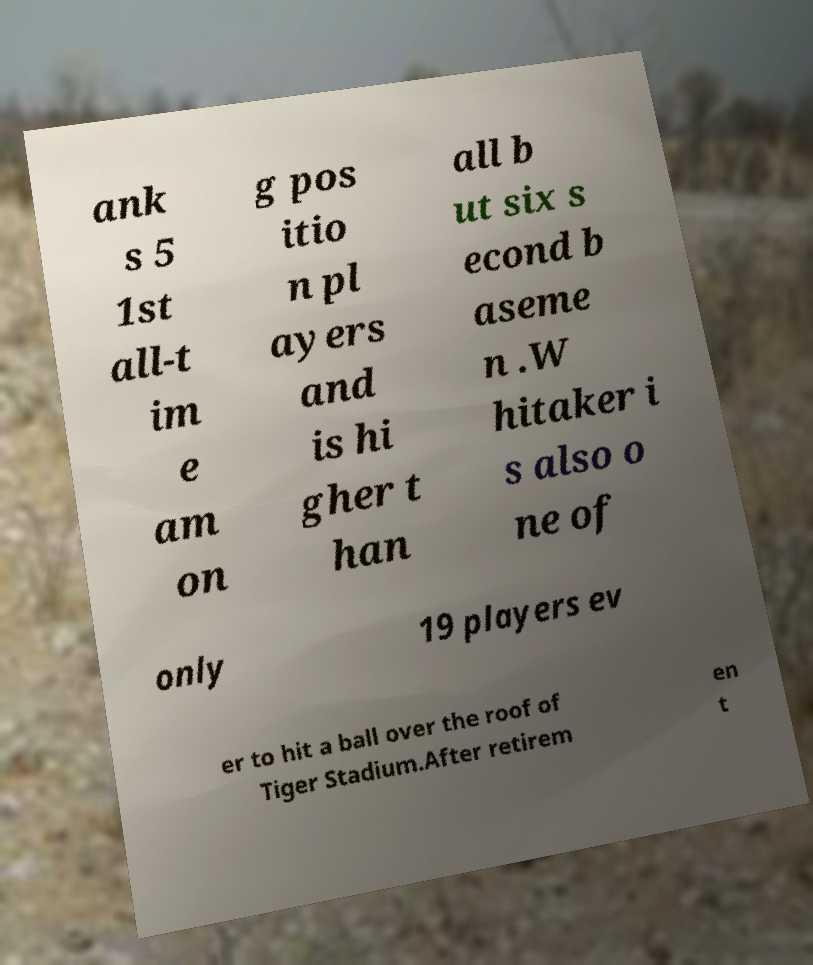Can you read and provide the text displayed in the image?This photo seems to have some interesting text. Can you extract and type it out for me? ank s 5 1st all-t im e am on g pos itio n pl ayers and is hi gher t han all b ut six s econd b aseme n .W hitaker i s also o ne of only 19 players ev er to hit a ball over the roof of Tiger Stadium.After retirem en t 